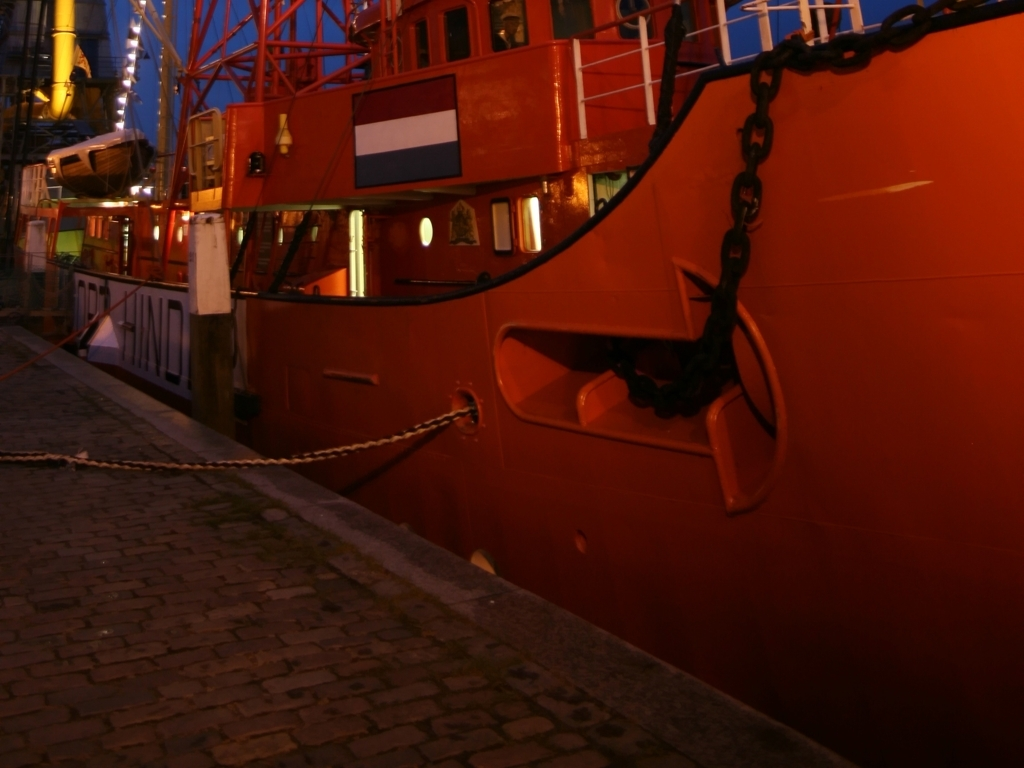What time of day does this image suggest, and how can you tell? The image suggests it was taken during the evening or night, which is evidenced by the artificial lighting reflecting on the surfaces of the ship and the darkness in the sky, indicating the absence of natural sunlight. Does the image convey any particular mood or atmosphere? The image conveys a serene yet industrial atmosphere, highlighted by the warm colors of the ship under artificial light, the absence of people, and the stillness of the water. It seems to capture a moment of calm during a period typically active for an area with docks and ships. 